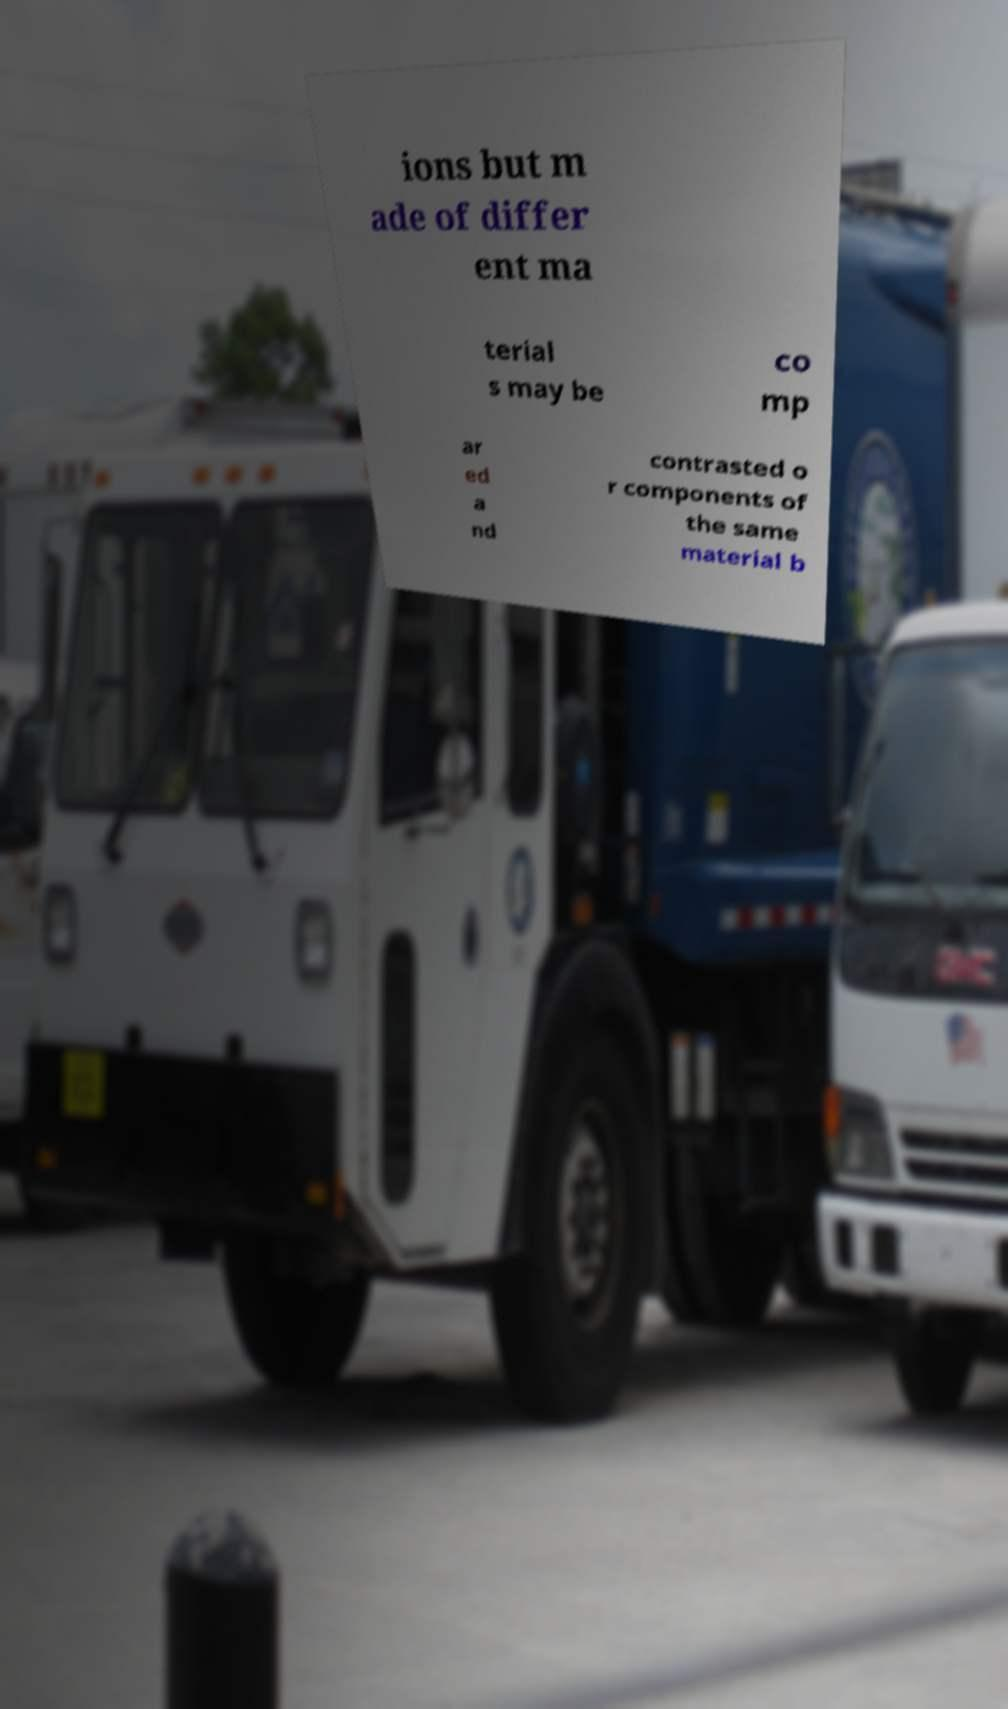I need the written content from this picture converted into text. Can you do that? ions but m ade of differ ent ma terial s may be co mp ar ed a nd contrasted o r components of the same material b 